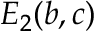Convert formula to latex. <formula><loc_0><loc_0><loc_500><loc_500>E _ { 2 } ( b , c )</formula> 